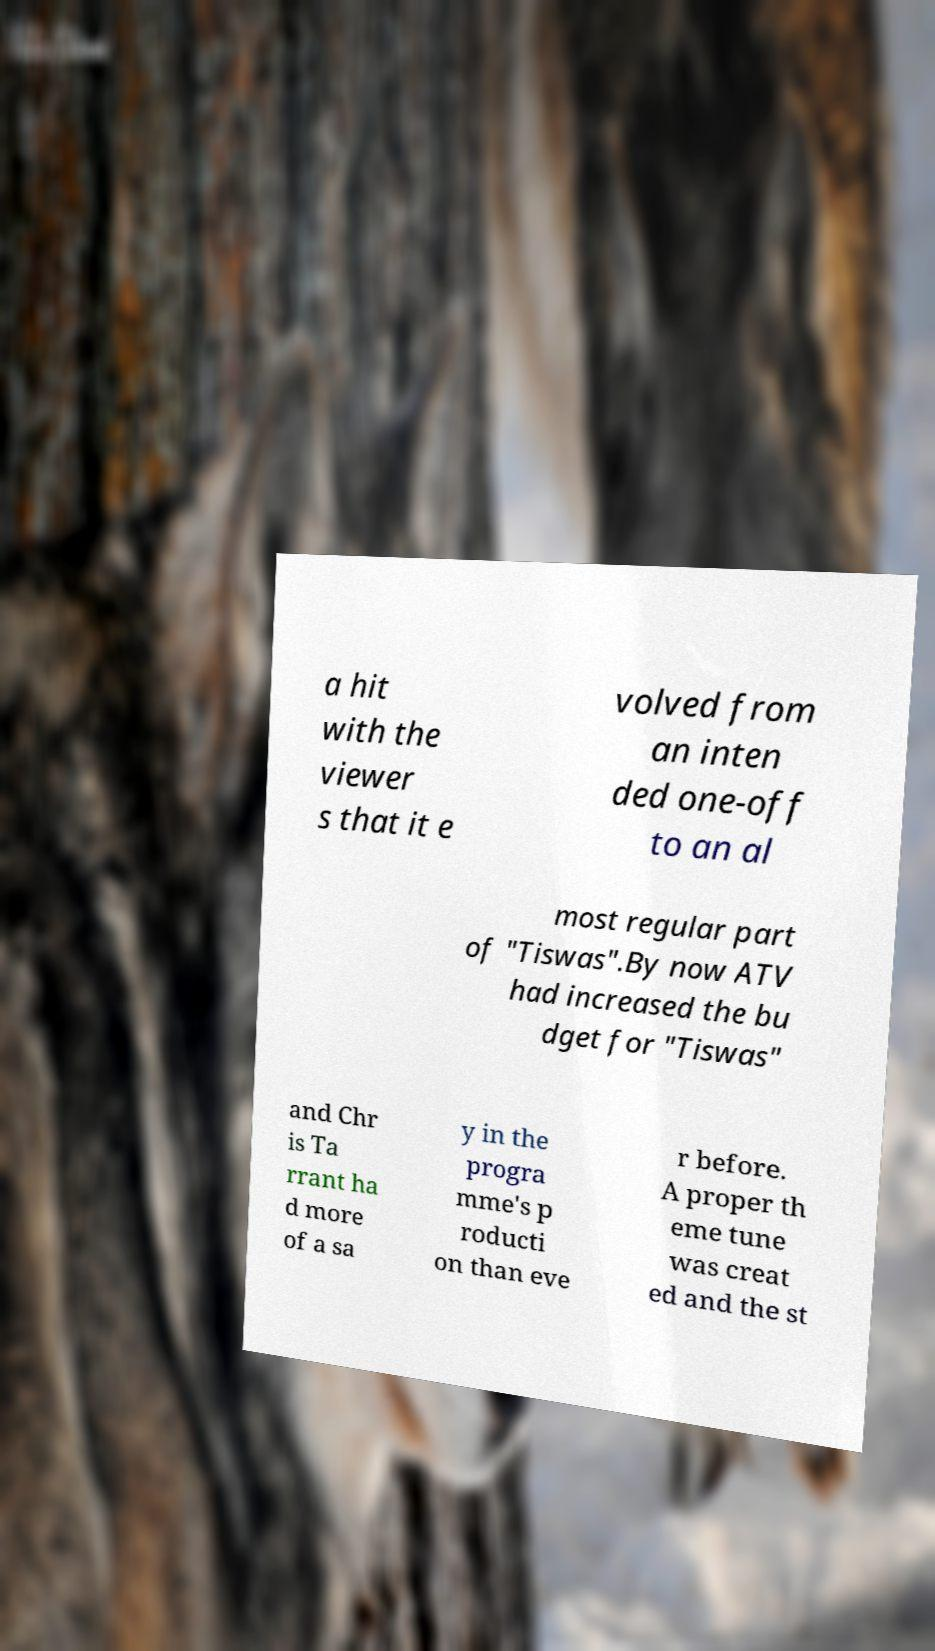For documentation purposes, I need the text within this image transcribed. Could you provide that? a hit with the viewer s that it e volved from an inten ded one-off to an al most regular part of "Tiswas".By now ATV had increased the bu dget for "Tiswas" and Chr is Ta rrant ha d more of a sa y in the progra mme's p roducti on than eve r before. A proper th eme tune was creat ed and the st 